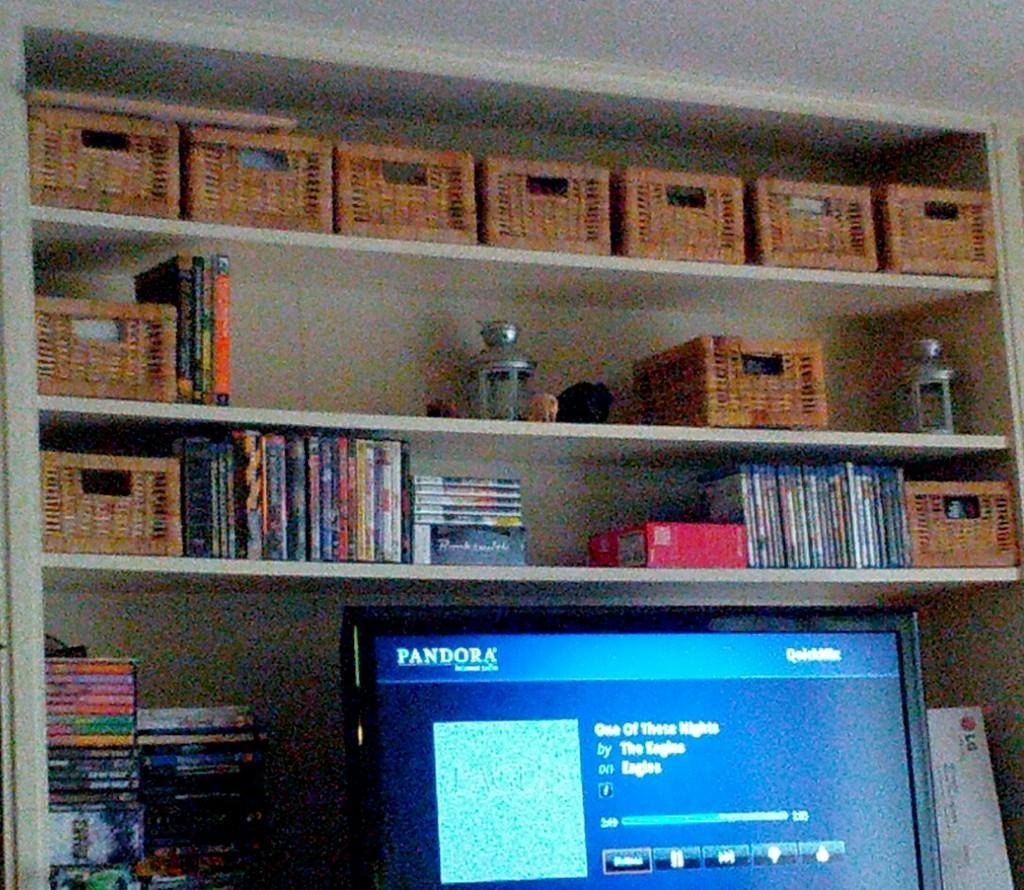How would you summarize this image in a sentence or two? In the foreground of the image we can see a television. In the background , we can see group of books, baskets placed on the racks. 